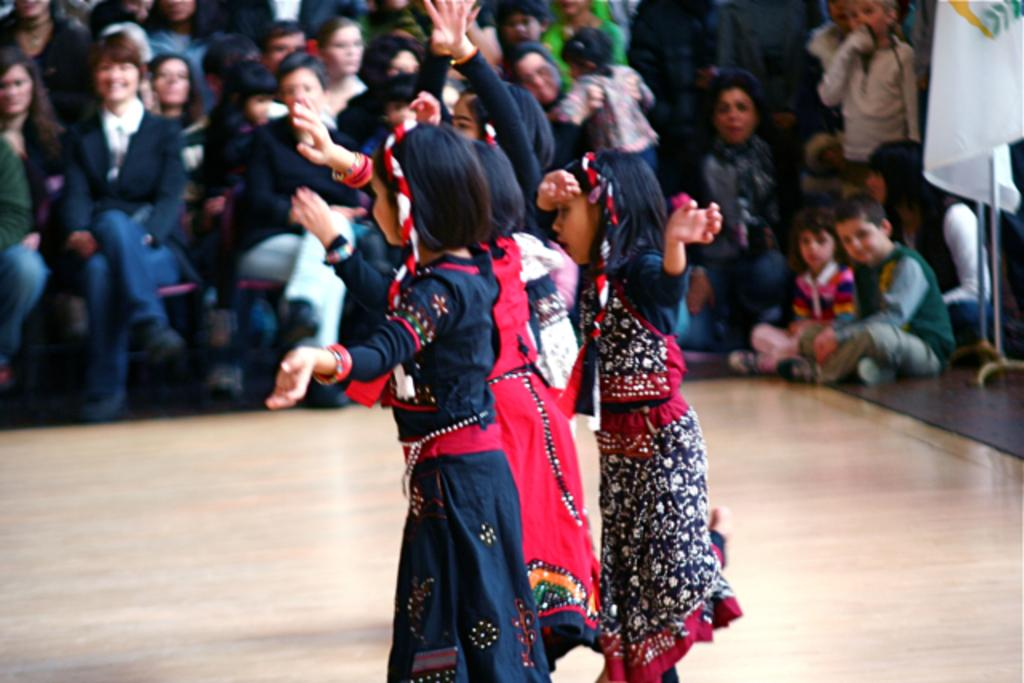What is the main subject of the image? The main subject of the image is a group of kids standing on the floor. Where are the kids located in the image? The group of kids is at the bottom of the image. What can be seen in the background of the image? There is a crowd in the background of the image. What is located on the right side of the image? There is a flag on the right side of the image. What historical event is being commemorated by the kids in the image? There is no indication of a historical event in the image; it simply shows a group of kids standing on the floor. Can you see a tiger in the image? No, there is no tiger present in the image. 